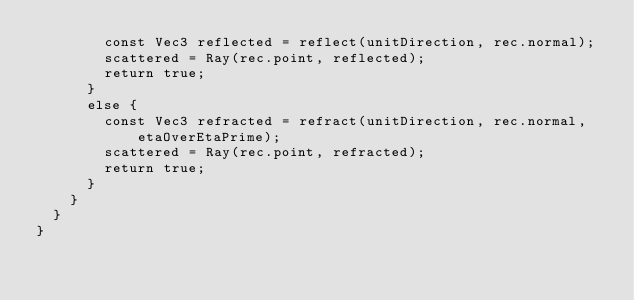Convert code to text. <code><loc_0><loc_0><loc_500><loc_500><_Cuda_>				const Vec3 reflected = reflect(unitDirection, rec.normal);
				scattered = Ray(rec.point, reflected);
				return true;
			}
			else {
				const Vec3 refracted = refract(unitDirection, rec.normal, etaOverEtaPrime);
				scattered = Ray(rec.point, refracted);
				return true;
			}
		}
	}
}
</code> 